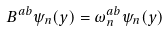<formula> <loc_0><loc_0><loc_500><loc_500>B ^ { a b } \psi _ { n } ( y ) = \omega ^ { a b } _ { n } \psi _ { n } ( y )</formula> 